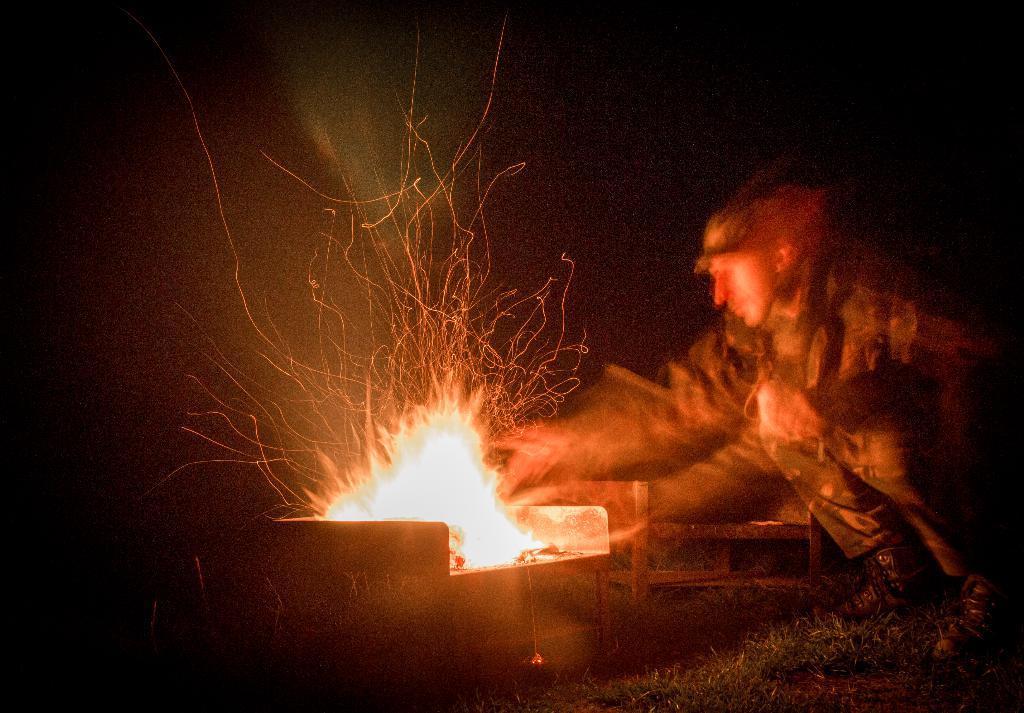In one or two sentences, can you explain what this image depicts? In the picture we can see a person sitting on the knees on the grass surface and he is with an army uniform with a cap and he is making a fire with twigs in the night. 